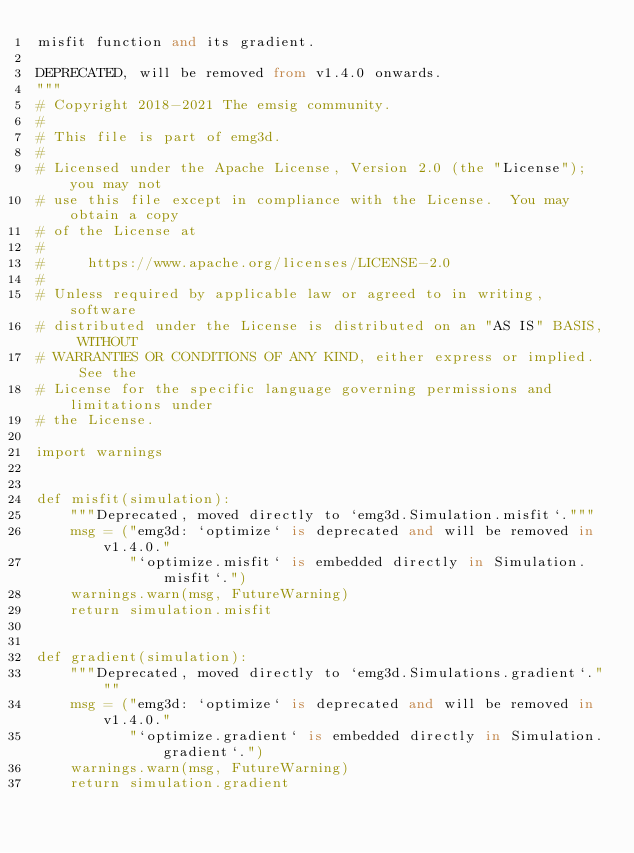<code> <loc_0><loc_0><loc_500><loc_500><_Python_>misfit function and its gradient.

DEPRECATED, will be removed from v1.4.0 onwards.
"""
# Copyright 2018-2021 The emsig community.
#
# This file is part of emg3d.
#
# Licensed under the Apache License, Version 2.0 (the "License"); you may not
# use this file except in compliance with the License.  You may obtain a copy
# of the License at
#
#     https://www.apache.org/licenses/LICENSE-2.0
#
# Unless required by applicable law or agreed to in writing, software
# distributed under the License is distributed on an "AS IS" BASIS, WITHOUT
# WARRANTIES OR CONDITIONS OF ANY KIND, either express or implied.  See the
# License for the specific language governing permissions and limitations under
# the License.

import warnings


def misfit(simulation):
    """Deprecated, moved directly to `emg3d.Simulation.misfit`."""
    msg = ("emg3d: `optimize` is deprecated and will be removed in v1.4.0."
           "`optimize.misfit` is embedded directly in Simulation.misfit`.")
    warnings.warn(msg, FutureWarning)
    return simulation.misfit


def gradient(simulation):
    """Deprecated, moved directly to `emg3d.Simulations.gradient`."""
    msg = ("emg3d: `optimize` is deprecated and will be removed in v1.4.0."
           "`optimize.gradient` is embedded directly in Simulation.gradient`.")
    warnings.warn(msg, FutureWarning)
    return simulation.gradient
</code> 